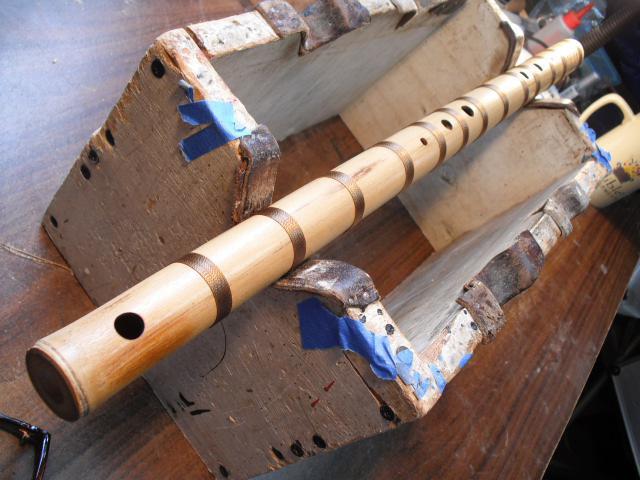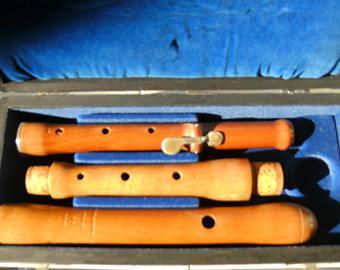The first image is the image on the left, the second image is the image on the right. For the images shown, is this caption "Each image features a wooden holder that displays flutes horizontally, and one of the flute holders stands upright on an oval base." true? Answer yes or no. No. The first image is the image on the left, the second image is the image on the right. Evaluate the accuracy of this statement regarding the images: "There are more instruments in the image on the right.". Is it true? Answer yes or no. Yes. 